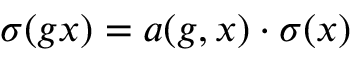<formula> <loc_0><loc_0><loc_500><loc_500>\sigma ( g x ) = a ( g , x ) \cdot \sigma ( x )</formula> 